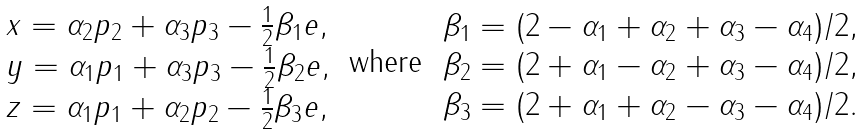<formula> <loc_0><loc_0><loc_500><loc_500>\begin{array} { l } x = \alpha _ { 2 } p _ { 2 } + \alpha _ { 3 } p _ { 3 } - \frac { 1 } { 2 } \beta _ { 1 } e , \\ y = \alpha _ { 1 } p _ { 1 } + \alpha _ { 3 } p _ { 3 } - \frac { 1 } { 2 } \beta _ { 2 } e , \\ z = \alpha _ { 1 } p _ { 1 } + \alpha _ { 2 } p _ { 2 } - \frac { 1 } { 2 } \beta _ { 3 } e , \end{array} \text { where } \begin{array} { l } \beta _ { 1 } = ( 2 - \alpha _ { 1 } + \alpha _ { 2 } + \alpha _ { 3 } - \alpha _ { 4 } ) / 2 , \\ \beta _ { 2 } = ( 2 + \alpha _ { 1 } - \alpha _ { 2 } + \alpha _ { 3 } - \alpha _ { 4 } ) / 2 , \\ \beta _ { 3 } = ( 2 + \alpha _ { 1 } + \alpha _ { 2 } - \alpha _ { 3 } - \alpha _ { 4 } ) / 2 . \end{array}</formula> 